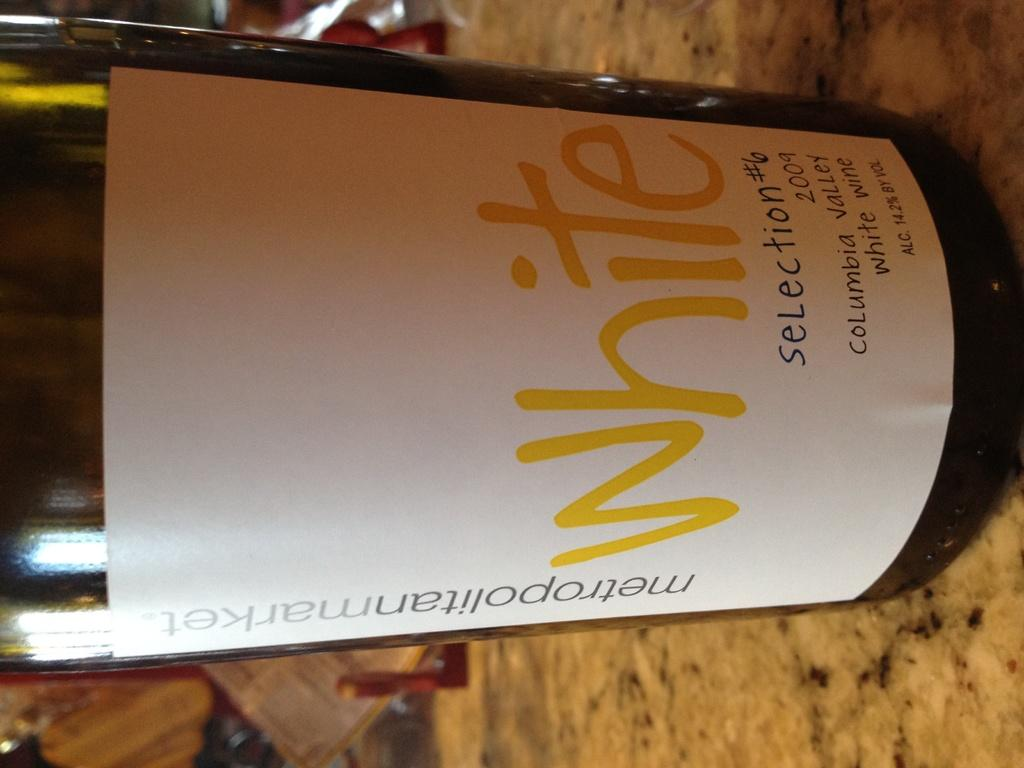<image>
Give a short and clear explanation of the subsequent image. A bottle of white wine from metropolitan market. 